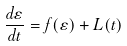<formula> <loc_0><loc_0><loc_500><loc_500>\frac { d \varepsilon } { d t } = f ( \varepsilon ) + L ( t )</formula> 